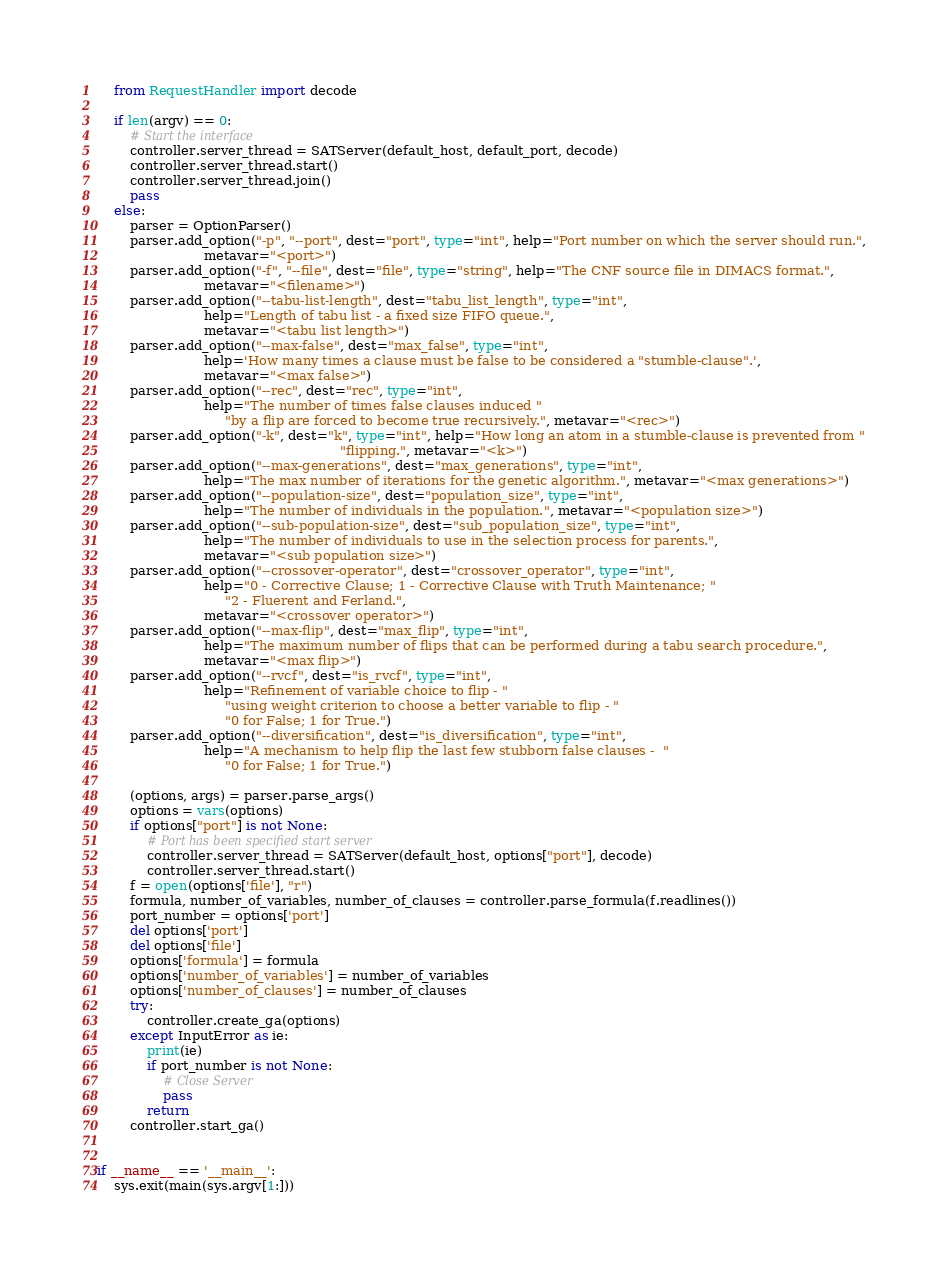Convert code to text. <code><loc_0><loc_0><loc_500><loc_500><_Python_>    from RequestHandler import decode

    if len(argv) == 0:
        # Start the interface
        controller.server_thread = SATServer(default_host, default_port, decode)
        controller.server_thread.start()
        controller.server_thread.join()
        pass
    else:
        parser = OptionParser()
        parser.add_option("-p", "--port", dest="port", type="int", help="Port number on which the server should run.",
                          metavar="<port>")
        parser.add_option("-f", "--file", dest="file", type="string", help="The CNF source file in DIMACS format.",
                          metavar="<filename>")
        parser.add_option("--tabu-list-length", dest="tabu_list_length", type="int",
                          help="Length of tabu list - a fixed size FIFO queue.",
                          metavar="<tabu list length>")
        parser.add_option("--max-false", dest="max_false", type="int",
                          help='How many times a clause must be false to be considered a "stumble-clause".',
                          metavar="<max false>")
        parser.add_option("--rec", dest="rec", type="int",
                          help="The number of times false clauses induced "
                               "by a flip are forced to become true recursively.", metavar="<rec>")
        parser.add_option("-k", dest="k", type="int", help="How long an atom in a stumble-clause is prevented from "
                                                           "flipping.", metavar="<k>")
        parser.add_option("--max-generations", dest="max_generations", type="int",
                          help="The max number of iterations for the genetic algorithm.", metavar="<max generations>")
        parser.add_option("--population-size", dest="population_size", type="int",
                          help="The number of individuals in the population.", metavar="<population size>")
        parser.add_option("--sub-population-size", dest="sub_population_size", type="int",
                          help="The number of individuals to use in the selection process for parents.",
                          metavar="<sub population size>")
        parser.add_option("--crossover-operator", dest="crossover_operator", type="int",
                          help="0 - Corrective Clause; 1 - Corrective Clause with Truth Maintenance; "
                               "2 - Fluerent and Ferland.",
                          metavar="<crossover operator>")
        parser.add_option("--max-flip", dest="max_flip", type="int",
                          help="The maximum number of flips that can be performed during a tabu search procedure.",
                          metavar="<max flip>")
        parser.add_option("--rvcf", dest="is_rvcf", type="int",
                          help="Refinement of variable choice to flip - "
                               "using weight criterion to choose a better variable to flip - "
                               "0 for False; 1 for True.")
        parser.add_option("--diversification", dest="is_diversification", type="int",
                          help="A mechanism to help flip the last few stubborn false clauses -  "
                               "0 for False; 1 for True.")

        (options, args) = parser.parse_args()
        options = vars(options)
        if options["port"] is not None:
            # Port has been specified start server
            controller.server_thread = SATServer(default_host, options["port"], decode)
            controller.server_thread.start()
        f = open(options['file'], "r")
        formula, number_of_variables, number_of_clauses = controller.parse_formula(f.readlines())
        port_number = options['port']
        del options['port']
        del options['file']
        options['formula'] = formula
        options['number_of_variables'] = number_of_variables
        options['number_of_clauses'] = number_of_clauses
        try:
            controller.create_ga(options)
        except InputError as ie:
            print(ie)
            if port_number is not None:
                # Close Server
                pass
            return
        controller.start_ga()


if __name__ == '__main__':
    sys.exit(main(sys.argv[1:]))
</code> 